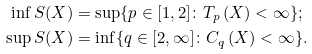<formula> <loc_0><loc_0><loc_500><loc_500>\inf S ( X ) & = \sup \{ p \in [ 1 , 2 ] \colon T _ { p } \left ( X \right ) < \infty \} ; \\ \sup S ( X ) & = \inf \{ q \in [ 2 , \infty ] \colon C _ { q } \left ( X \right ) < \infty \} .</formula> 